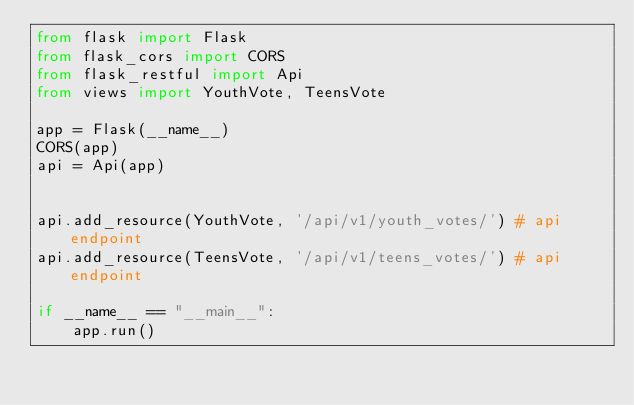Convert code to text. <code><loc_0><loc_0><loc_500><loc_500><_Python_>from flask import Flask
from flask_cors import CORS
from flask_restful import Api
from views import YouthVote, TeensVote

app = Flask(__name__)
CORS(app)
api = Api(app)


api.add_resource(YouthVote, '/api/v1/youth_votes/') # api endpoint
api.add_resource(TeensVote, '/api/v1/teens_votes/') # api endpoint

if __name__ == "__main__":
    app.run()</code> 